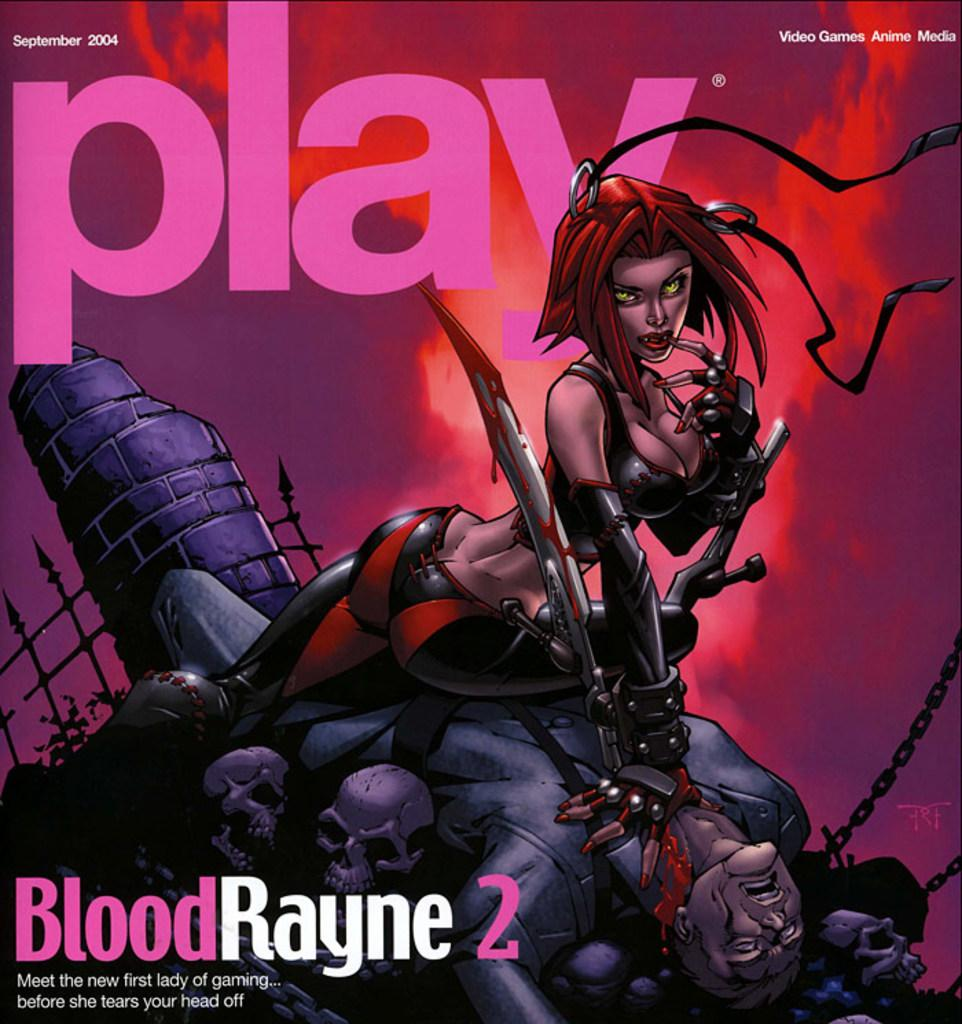What type of picture is being described? The picture being described is an animated picture. What can be seen in the animated picture? There are people, weapons, chains, a fence, and a plant in the animated picture. What word is written in the animated picture? The word "skulls" is written in the animated picture. What channel is the animated picture being broadcasted on? The facts provided do not mention any information about the channel on which the animated picture is being broadcasted. How many feet are visible in the animated picture? There is no information provided about feet being visible in the animated picture. 